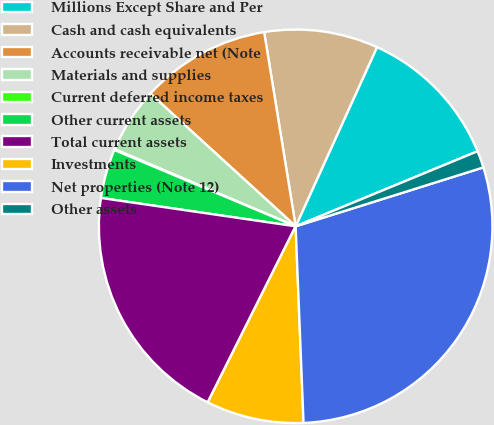Convert chart. <chart><loc_0><loc_0><loc_500><loc_500><pie_chart><fcel>Millions Except Share and Per<fcel>Cash and cash equivalents<fcel>Accounts receivable net (Note<fcel>Materials and supplies<fcel>Current deferred income taxes<fcel>Other current assets<fcel>Total current assets<fcel>Investments<fcel>Net properties (Note 12)<fcel>Other assets<nl><fcel>11.99%<fcel>9.34%<fcel>10.66%<fcel>5.37%<fcel>0.07%<fcel>4.04%<fcel>19.93%<fcel>8.01%<fcel>29.2%<fcel>1.39%<nl></chart> 